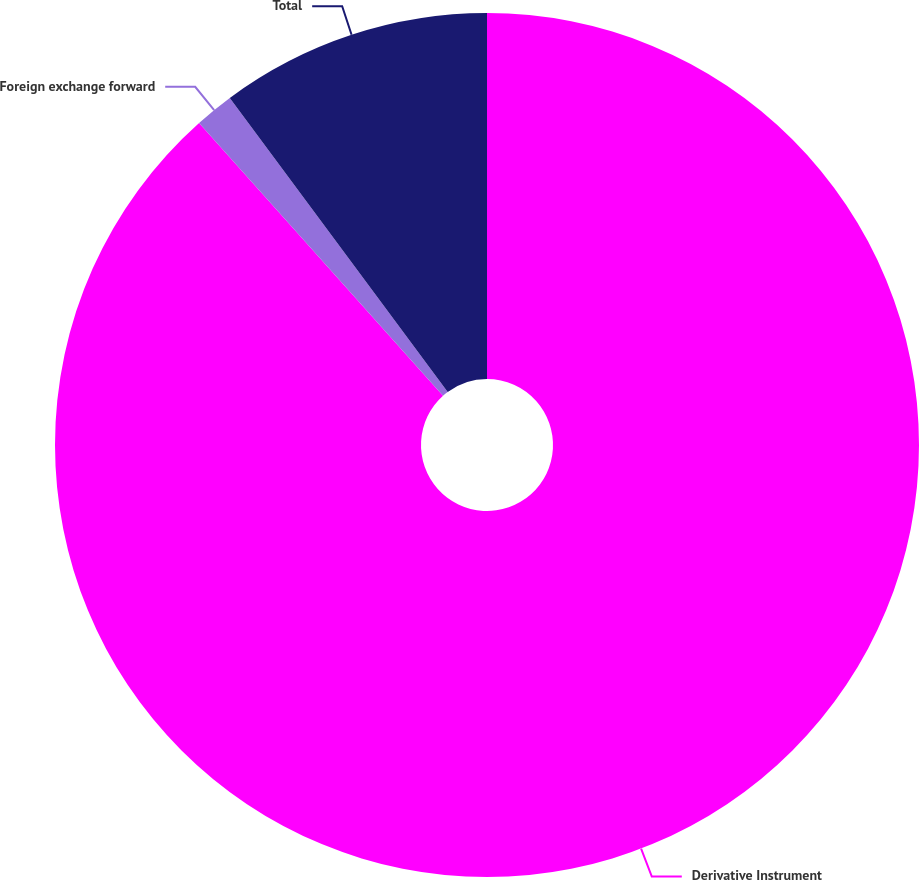Convert chart. <chart><loc_0><loc_0><loc_500><loc_500><pie_chart><fcel>Derivative Instrument<fcel>Foreign exchange forward<fcel>Total<nl><fcel>88.39%<fcel>1.46%<fcel>10.15%<nl></chart> 